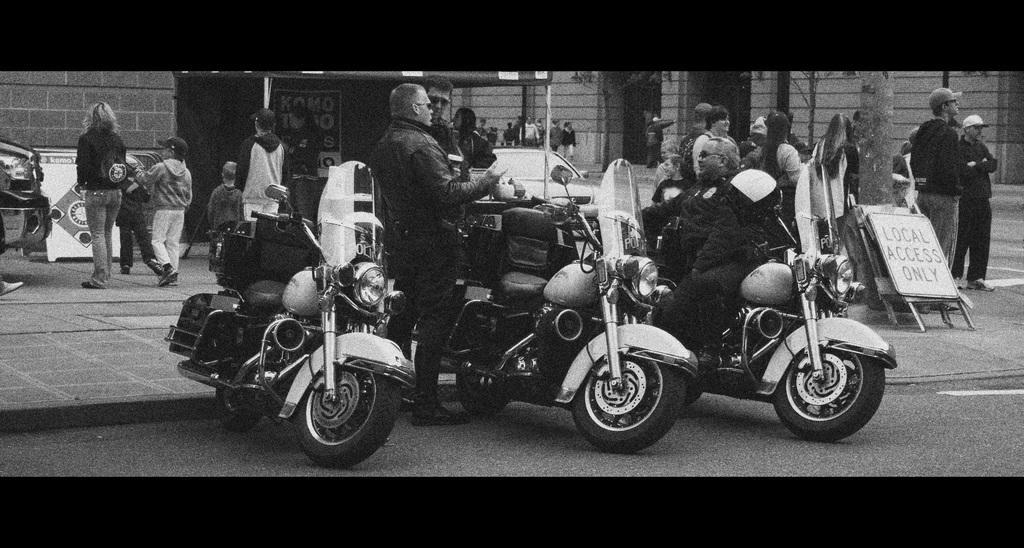Can you describe this image briefly? A black and white picture. A banner beside this wall. These persons are standing in-front of this motorbikes. Beside this tree there is a board. Far these persons are standing. 